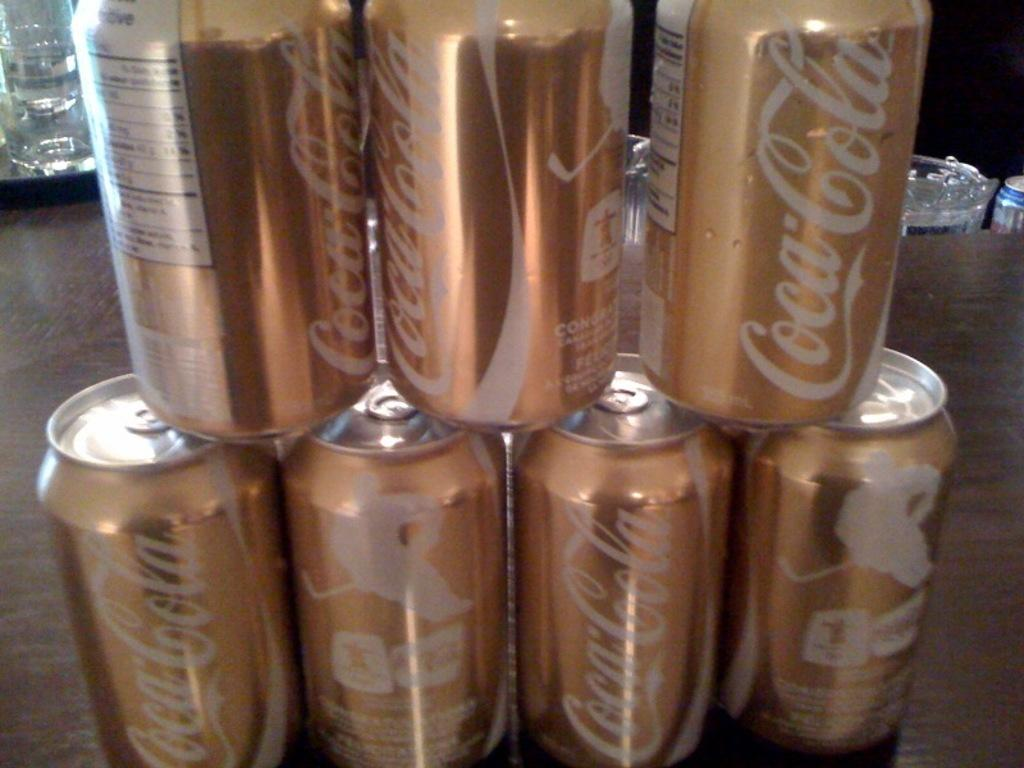<image>
Share a concise interpretation of the image provided. Gold Coca Cola cans with pictures of ice hockey players are stacked. 